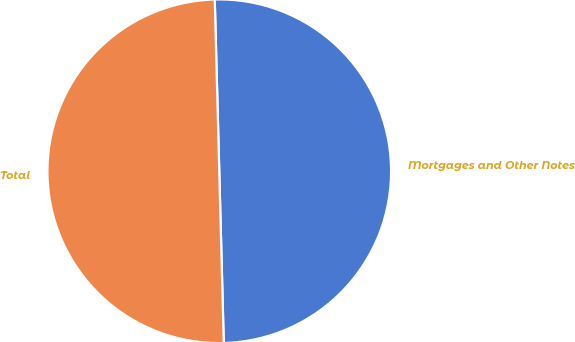<chart> <loc_0><loc_0><loc_500><loc_500><pie_chart><fcel>Mortgages and Other Notes<fcel>Total<nl><fcel>50.0%<fcel>50.0%<nl></chart> 